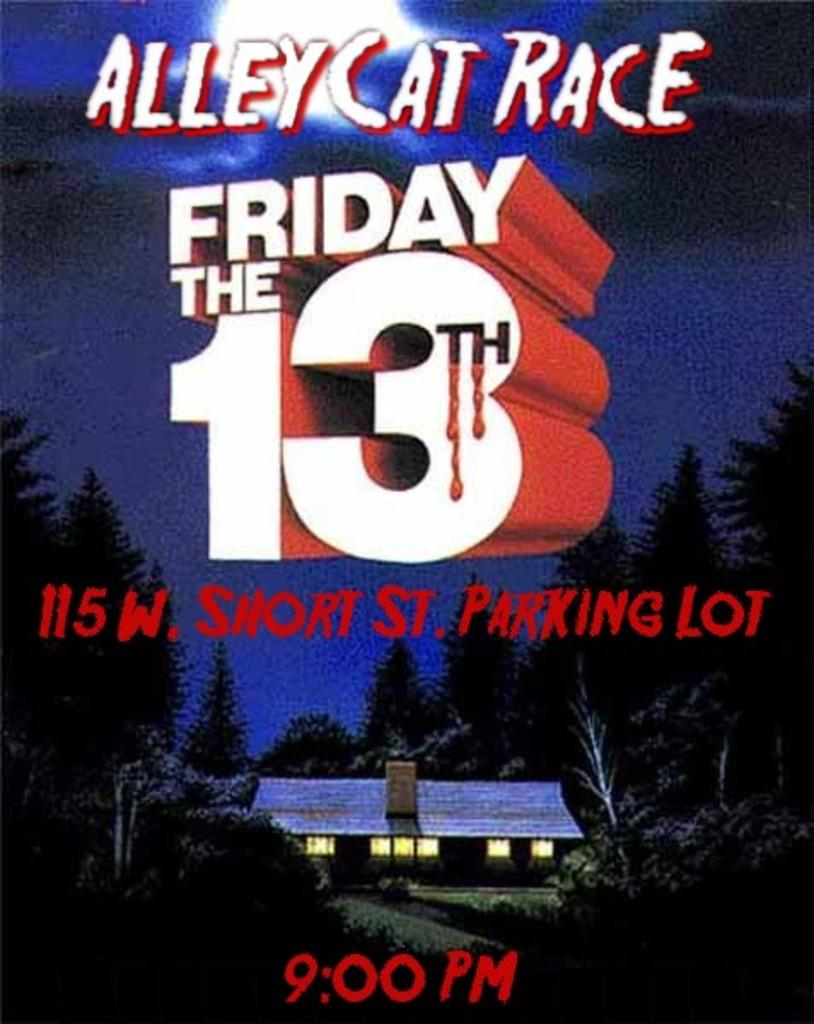<image>
Write a terse but informative summary of the picture. A house with lights on is beneath an ad for the Alleycat Race on Friday the 13th. 